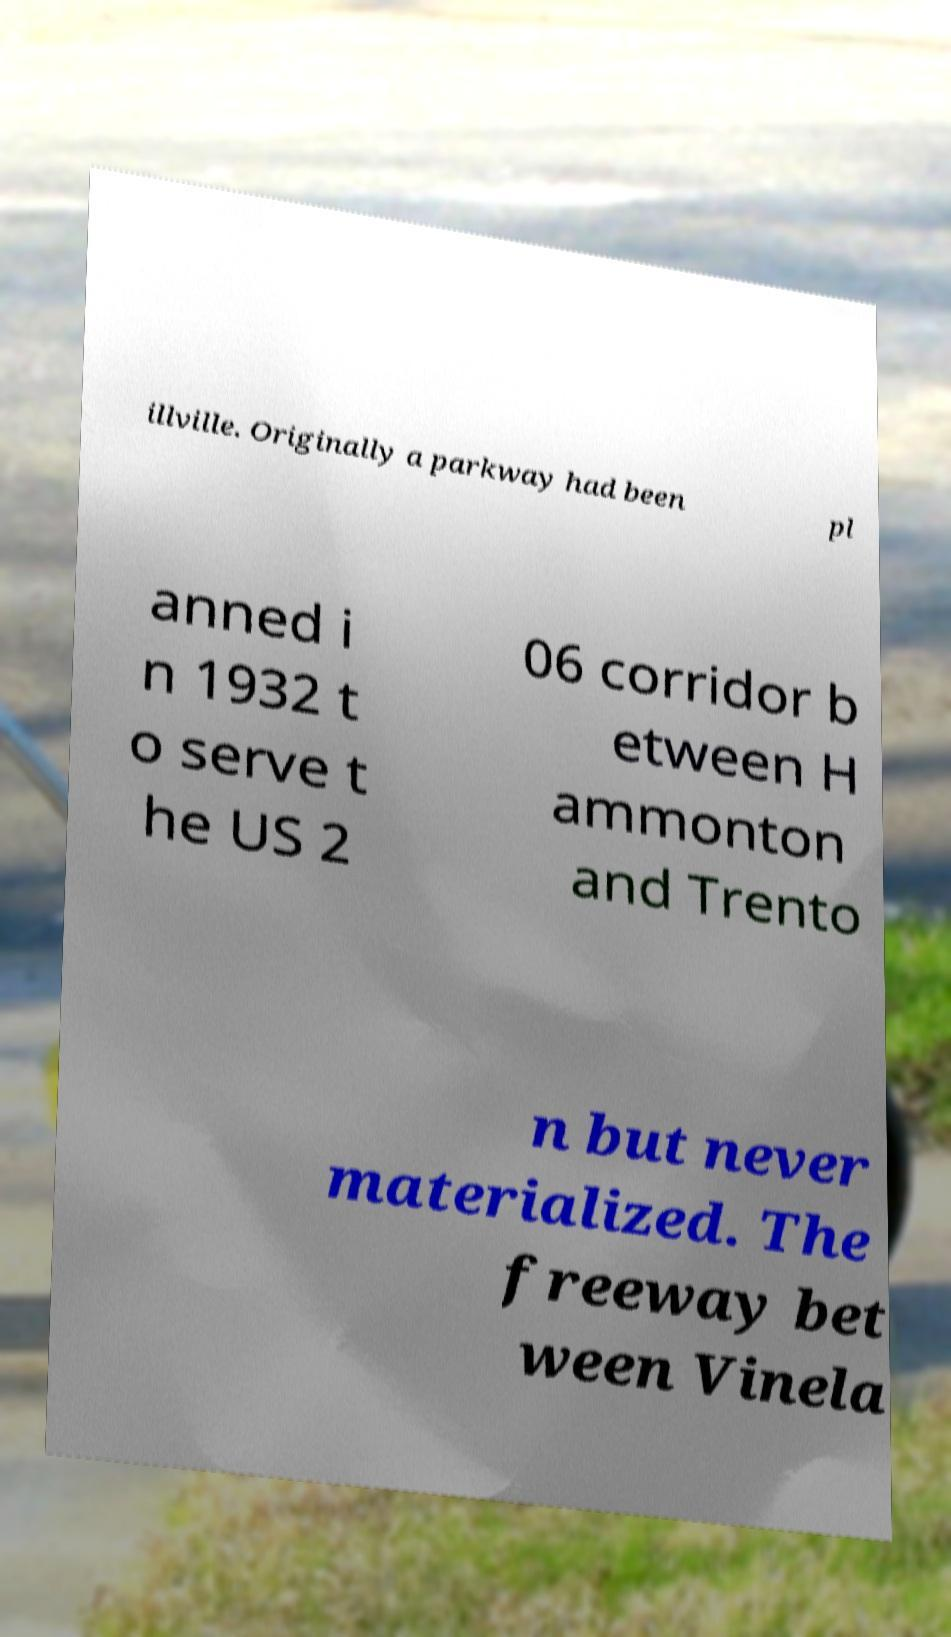There's text embedded in this image that I need extracted. Can you transcribe it verbatim? illville. Originally a parkway had been pl anned i n 1932 t o serve t he US 2 06 corridor b etween H ammonton and Trento n but never materialized. The freeway bet ween Vinela 